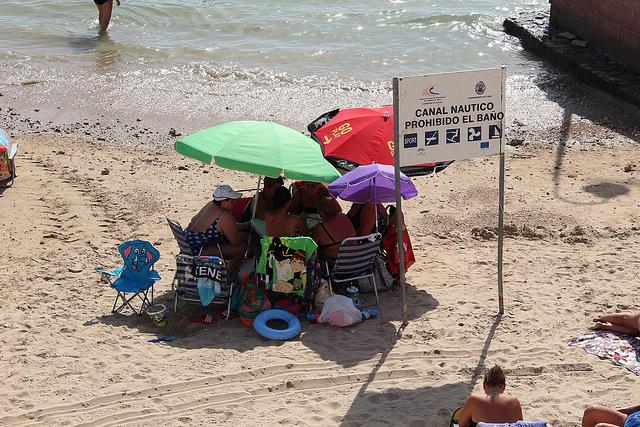What kinds of activities are prohibited here?
Keep it brief. Swimming. What color is the woman's umbrella?
Quick response, please. Green. What color is the umbrella on the left?
Keep it brief. Green. How many umbrellas are in the picture?
Write a very short answer. 3. What is the woman looking for in the gravel?
Keep it brief. Shells. 